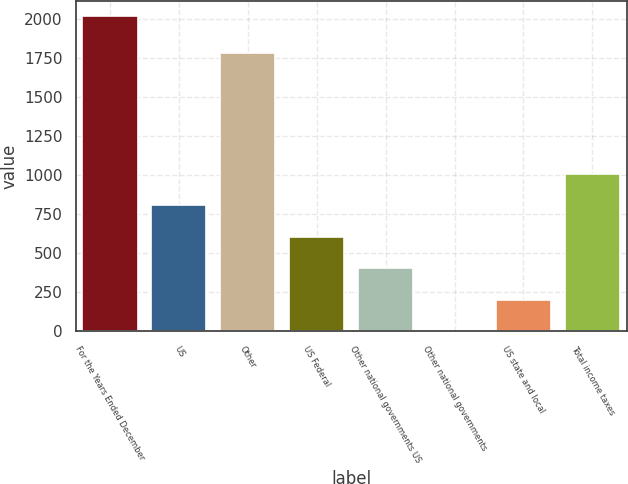Convert chart to OTSL. <chart><loc_0><loc_0><loc_500><loc_500><bar_chart><fcel>For the Years Ended December<fcel>US<fcel>Other<fcel>US Federal<fcel>Other national governments US<fcel>Other national governments<fcel>US state and local<fcel>Total income taxes<nl><fcel>2018<fcel>807.8<fcel>1784<fcel>606.1<fcel>404.4<fcel>1<fcel>202.7<fcel>1009.5<nl></chart> 